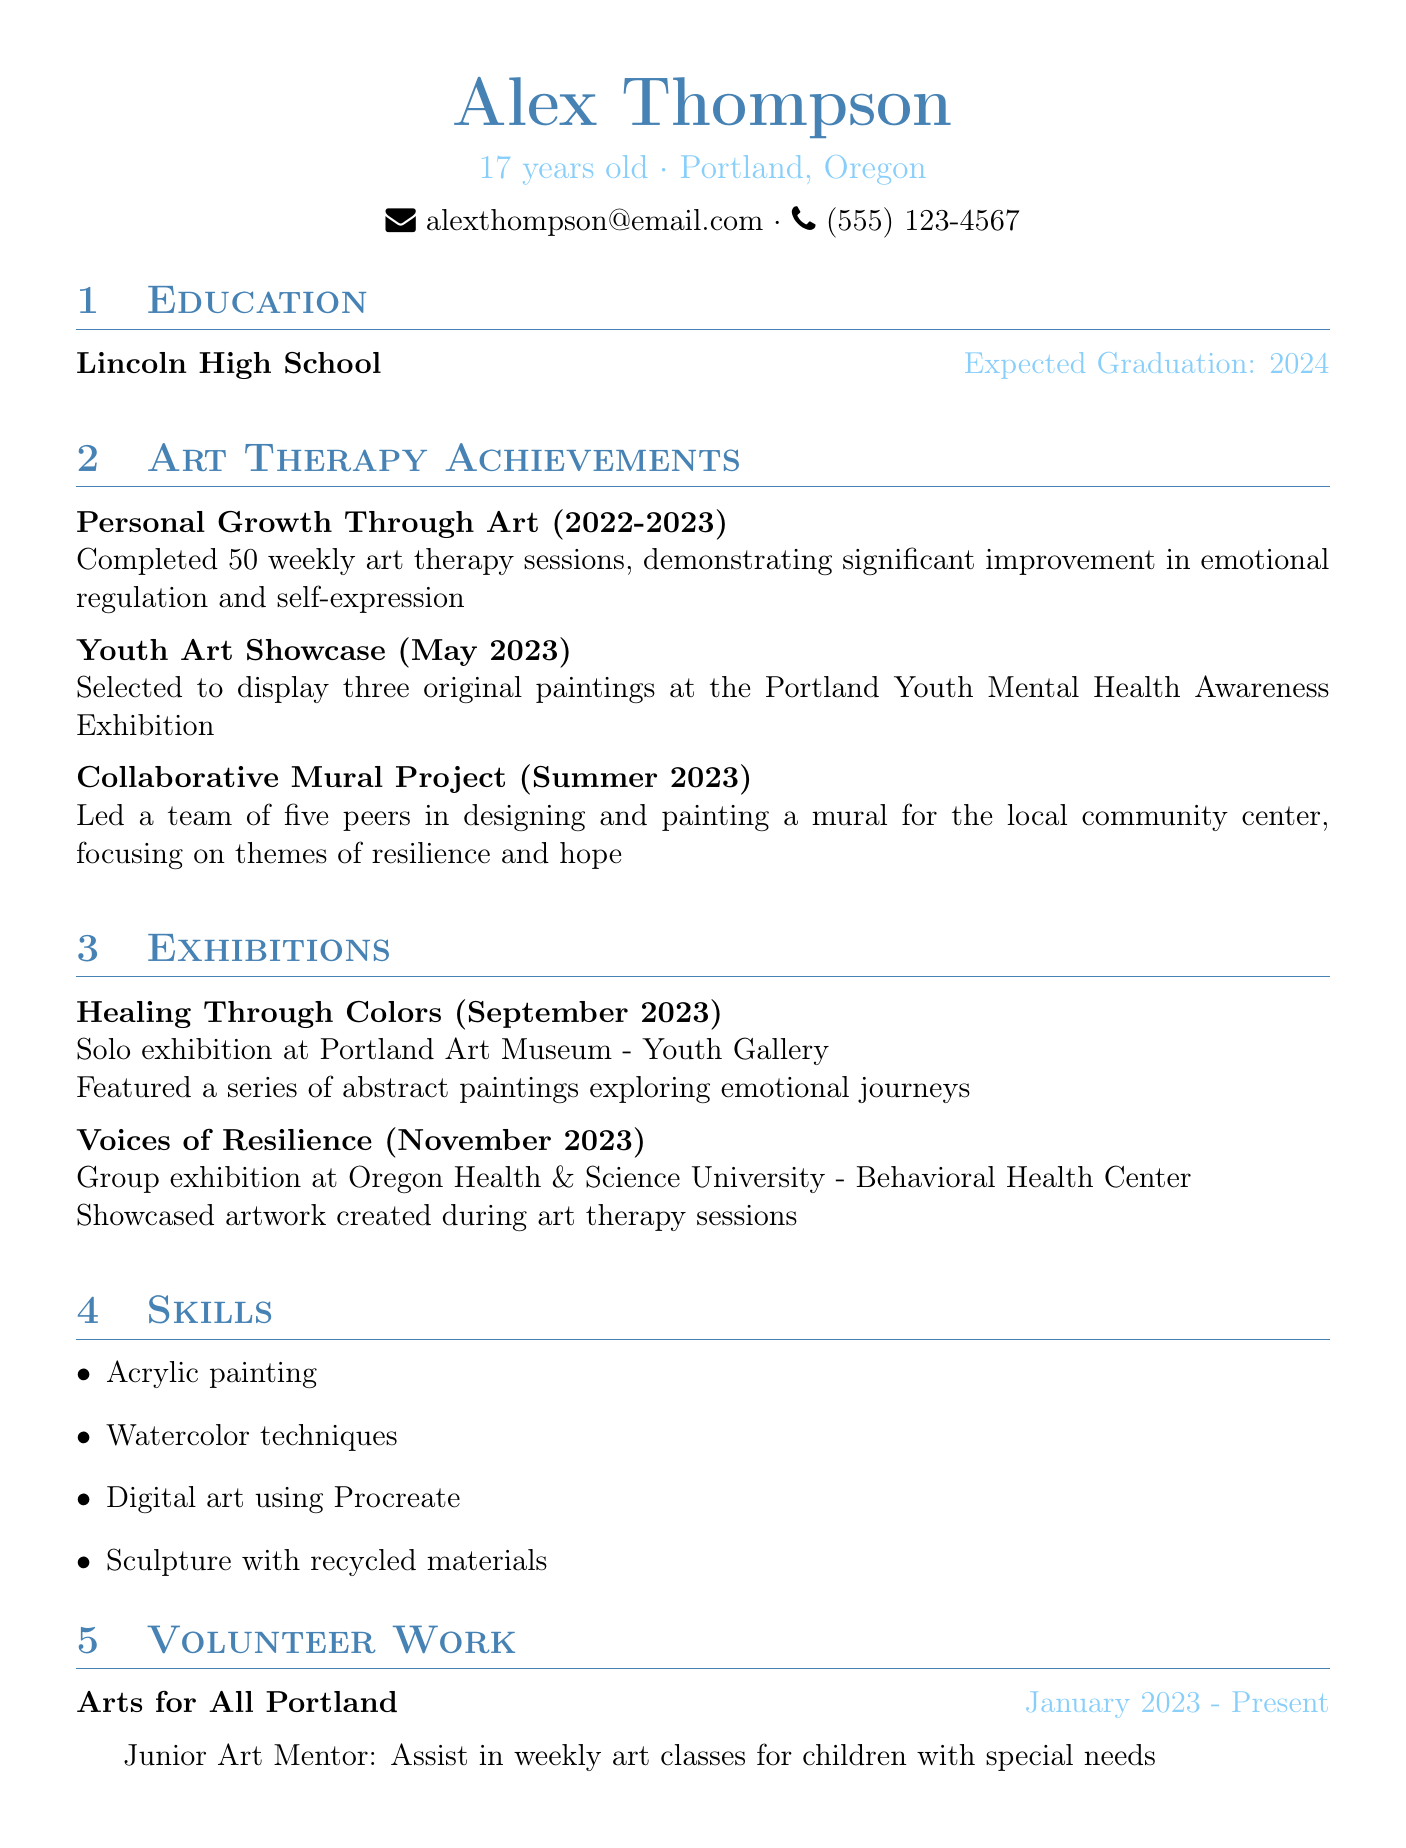What is the name of the individual? The individual's name is listed at the top of the document.
Answer: Alex Thompson What is the expected graduation year? The expected graduation year is mentioned in the education section.
Answer: 2024 How many art therapy sessions were completed? The number of art therapy sessions is specified in the achievements section.
Answer: 50 Which venue hosted the solo exhibition "Healing Through Colors"? The venue for the exhibition is described in the exhibitions section.
Answer: Portland Art Museum - Youth Gallery What role does Alex Thompson hold at Arts for All Portland? The role is mentioned in the volunteer work section.
Answer: Junior Art Mentor In what year did the Youth Art Showcase take place? The year of the Youth Art Showcase is provided in the achievements section.
Answer: 2023 What was the focus of the mural project? The focus of the mural project is described in the achievements section.
Answer: Resilience and hope What type of art techniques is Alex skilled in? The skills section lists several art techniques Alex is proficient in.
Answer: Acrylic painting, Watercolor techniques, Digital art using Procreate, Sculpture with recycled materials What type of exhibition is "Voices of Resilience"? The type of exhibition is stated in the exhibitions section.
Answer: Group exhibition 